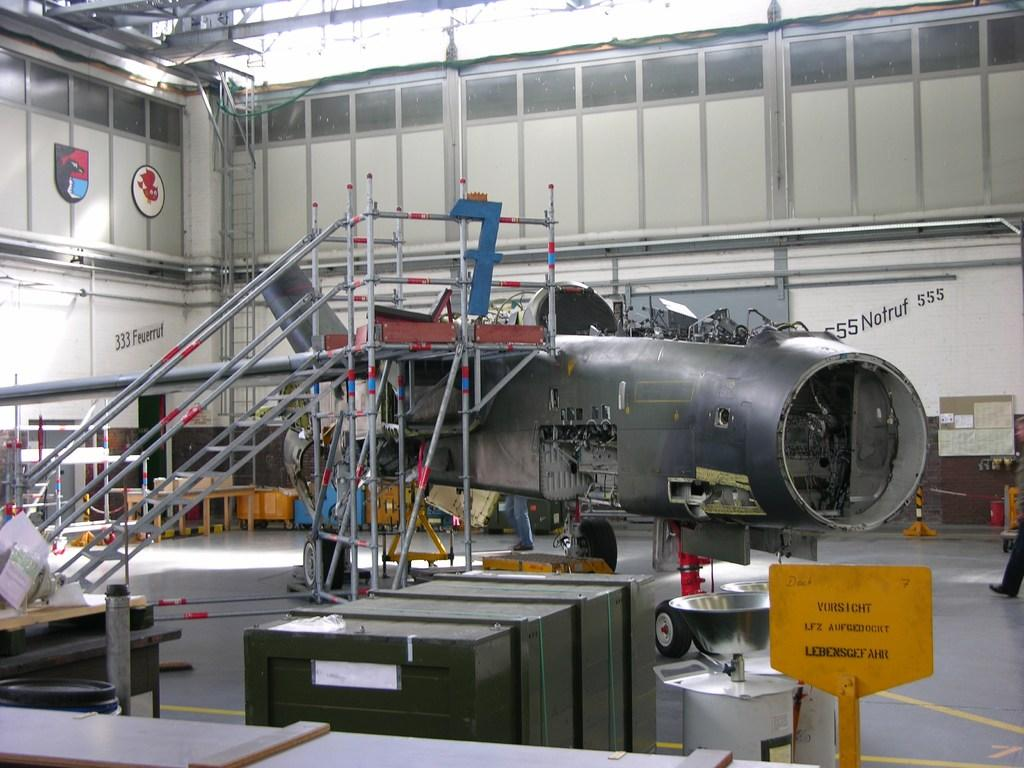What is the main subject of the image? The main subject of the image is the construction of an aircraft. What type of accessory is present in the image for reaching higher areas? There is a staircase and ladders in the image for reaching higher areas. What type of containers are present in the image? Cardboard boxes are present in the image. What type of furniture is visible in the image? Tables are visible in the image. Can you describe any other objects in the image? There are other unspecified objects in the image. What type of animal can be seen playing with a grip in the image? There is no animal or grip present in the image; it focuses on the construction of an aircraft and related objects. 